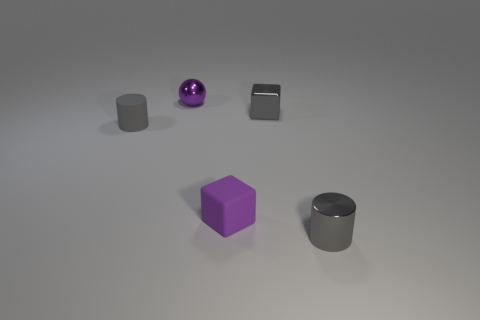Add 4 big brown objects. How many objects exist? 9 Subtract all cubes. How many objects are left? 3 Subtract 0 brown balls. How many objects are left? 5 Subtract all cyan cylinders. Subtract all cylinders. How many objects are left? 3 Add 4 gray cubes. How many gray cubes are left? 5 Add 3 cyan shiny cylinders. How many cyan shiny cylinders exist? 3 